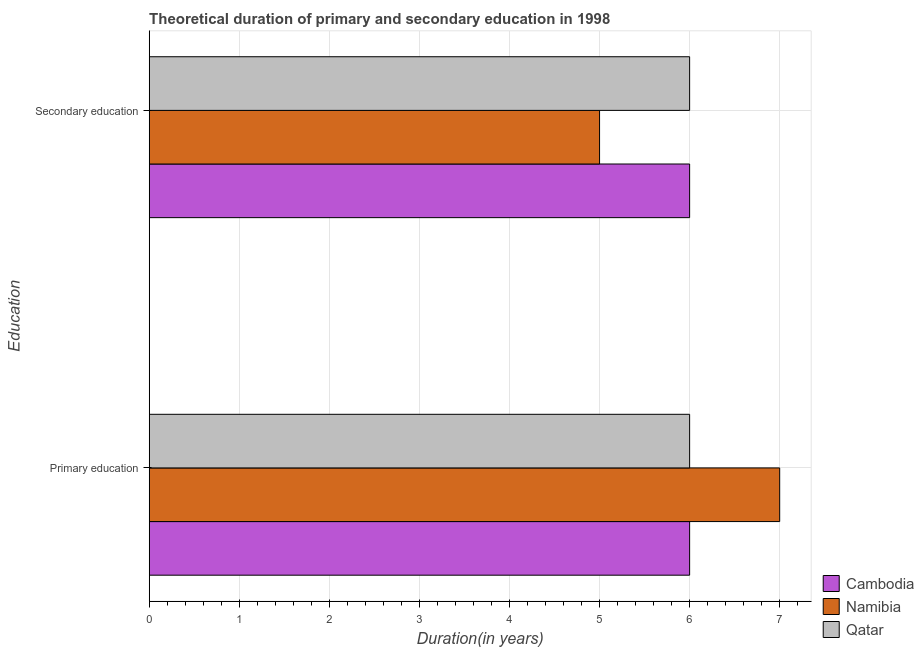Are the number of bars per tick equal to the number of legend labels?
Provide a succinct answer. Yes. Are the number of bars on each tick of the Y-axis equal?
Offer a terse response. Yes. How many bars are there on the 2nd tick from the bottom?
Your response must be concise. 3. What is the label of the 1st group of bars from the top?
Ensure brevity in your answer.  Secondary education. What is the duration of secondary education in Cambodia?
Make the answer very short. 6. Across all countries, what is the maximum duration of primary education?
Provide a short and direct response. 7. Across all countries, what is the minimum duration of secondary education?
Ensure brevity in your answer.  5. In which country was the duration of primary education maximum?
Provide a succinct answer. Namibia. In which country was the duration of primary education minimum?
Provide a succinct answer. Cambodia. What is the total duration of secondary education in the graph?
Your answer should be very brief. 17. What is the difference between the duration of secondary education in Namibia and the duration of primary education in Cambodia?
Keep it short and to the point. -1. What is the average duration of primary education per country?
Give a very brief answer. 6.33. In how many countries, is the duration of secondary education greater than 5.6 years?
Make the answer very short. 2. Is the duration of secondary education in Namibia less than that in Cambodia?
Your answer should be very brief. Yes. In how many countries, is the duration of secondary education greater than the average duration of secondary education taken over all countries?
Make the answer very short. 2. What does the 2nd bar from the top in Secondary education represents?
Ensure brevity in your answer.  Namibia. What does the 2nd bar from the bottom in Secondary education represents?
Ensure brevity in your answer.  Namibia. How many bars are there?
Make the answer very short. 6. How many countries are there in the graph?
Provide a succinct answer. 3. What is the difference between two consecutive major ticks on the X-axis?
Offer a very short reply. 1. Where does the legend appear in the graph?
Ensure brevity in your answer.  Bottom right. What is the title of the graph?
Provide a short and direct response. Theoretical duration of primary and secondary education in 1998. What is the label or title of the X-axis?
Your answer should be compact. Duration(in years). What is the label or title of the Y-axis?
Ensure brevity in your answer.  Education. What is the Duration(in years) of Cambodia in Primary education?
Offer a terse response. 6. What is the Duration(in years) of Qatar in Primary education?
Your answer should be very brief. 6. What is the Duration(in years) in Cambodia in Secondary education?
Your answer should be very brief. 6. What is the Duration(in years) in Namibia in Secondary education?
Make the answer very short. 5. What is the Duration(in years) in Qatar in Secondary education?
Provide a short and direct response. 6. Across all Education, what is the maximum Duration(in years) in Cambodia?
Keep it short and to the point. 6. Across all Education, what is the minimum Duration(in years) of Qatar?
Ensure brevity in your answer.  6. What is the total Duration(in years) of Cambodia in the graph?
Your answer should be very brief. 12. What is the total Duration(in years) of Namibia in the graph?
Provide a short and direct response. 12. What is the difference between the Duration(in years) of Namibia in Primary education and that in Secondary education?
Provide a succinct answer. 2. What is the average Duration(in years) of Cambodia per Education?
Offer a very short reply. 6. What is the average Duration(in years) of Qatar per Education?
Your answer should be very brief. 6. What is the difference between the Duration(in years) in Cambodia and Duration(in years) in Namibia in Primary education?
Keep it short and to the point. -1. What is the difference between the Duration(in years) of Namibia and Duration(in years) of Qatar in Primary education?
Your answer should be compact. 1. What is the difference between the Duration(in years) in Cambodia and Duration(in years) in Namibia in Secondary education?
Provide a short and direct response. 1. What is the difference between the Duration(in years) in Cambodia and Duration(in years) in Qatar in Secondary education?
Ensure brevity in your answer.  0. What is the difference between the Duration(in years) of Namibia and Duration(in years) of Qatar in Secondary education?
Make the answer very short. -1. What is the ratio of the Duration(in years) in Cambodia in Primary education to that in Secondary education?
Offer a terse response. 1. What is the ratio of the Duration(in years) of Namibia in Primary education to that in Secondary education?
Provide a short and direct response. 1.4. What is the ratio of the Duration(in years) in Qatar in Primary education to that in Secondary education?
Your answer should be very brief. 1. What is the difference between the highest and the second highest Duration(in years) of Cambodia?
Offer a very short reply. 0. What is the difference between the highest and the second highest Duration(in years) in Namibia?
Ensure brevity in your answer.  2. What is the difference between the highest and the second highest Duration(in years) in Qatar?
Ensure brevity in your answer.  0. 